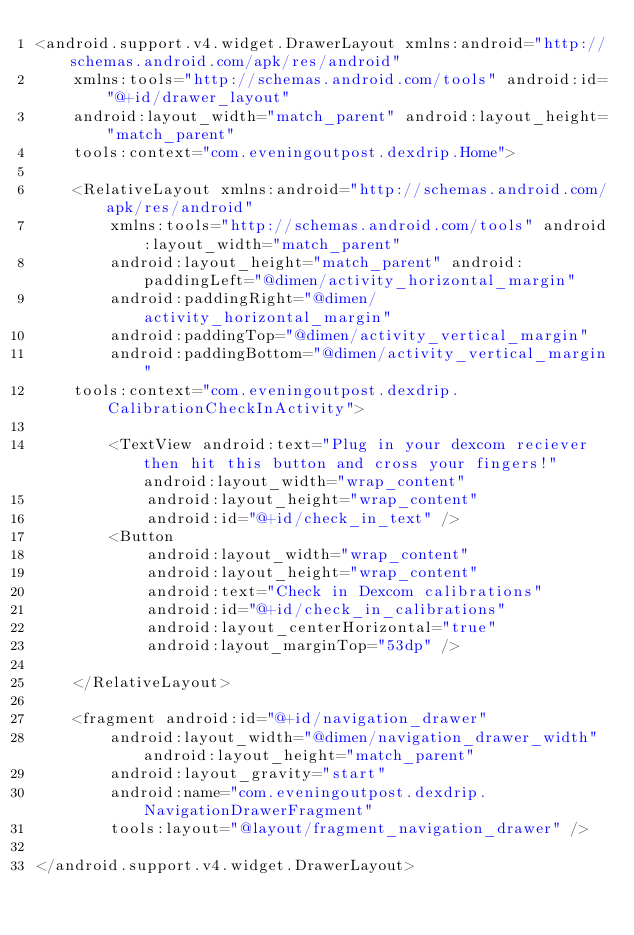Convert code to text. <code><loc_0><loc_0><loc_500><loc_500><_XML_><android.support.v4.widget.DrawerLayout xmlns:android="http://schemas.android.com/apk/res/android"
    xmlns:tools="http://schemas.android.com/tools" android:id="@+id/drawer_layout"
    android:layout_width="match_parent" android:layout_height="match_parent"
    tools:context="com.eveningoutpost.dexdrip.Home">

    <RelativeLayout xmlns:android="http://schemas.android.com/apk/res/android"
        xmlns:tools="http://schemas.android.com/tools" android:layout_width="match_parent"
        android:layout_height="match_parent" android:paddingLeft="@dimen/activity_horizontal_margin"
        android:paddingRight="@dimen/activity_horizontal_margin"
        android:paddingTop="@dimen/activity_vertical_margin"
        android:paddingBottom="@dimen/activity_vertical_margin"
    tools:context="com.eveningoutpost.dexdrip.CalibrationCheckInActivity">

        <TextView android:text="Plug in your dexcom reciever then hit this button and cross your fingers!" android:layout_width="wrap_content"
            android:layout_height="wrap_content"
            android:id="@+id/check_in_text" />
        <Button
            android:layout_width="wrap_content"
            android:layout_height="wrap_content"
            android:text="Check in Dexcom calibrations"
            android:id="@+id/check_in_calibrations"
            android:layout_centerHorizontal="true"
            android:layout_marginTop="53dp" />

    </RelativeLayout>

    <fragment android:id="@+id/navigation_drawer"
        android:layout_width="@dimen/navigation_drawer_width" android:layout_height="match_parent"
        android:layout_gravity="start"
        android:name="com.eveningoutpost.dexdrip.NavigationDrawerFragment"
        tools:layout="@layout/fragment_navigation_drawer" />

</android.support.v4.widget.DrawerLayout>
</code> 